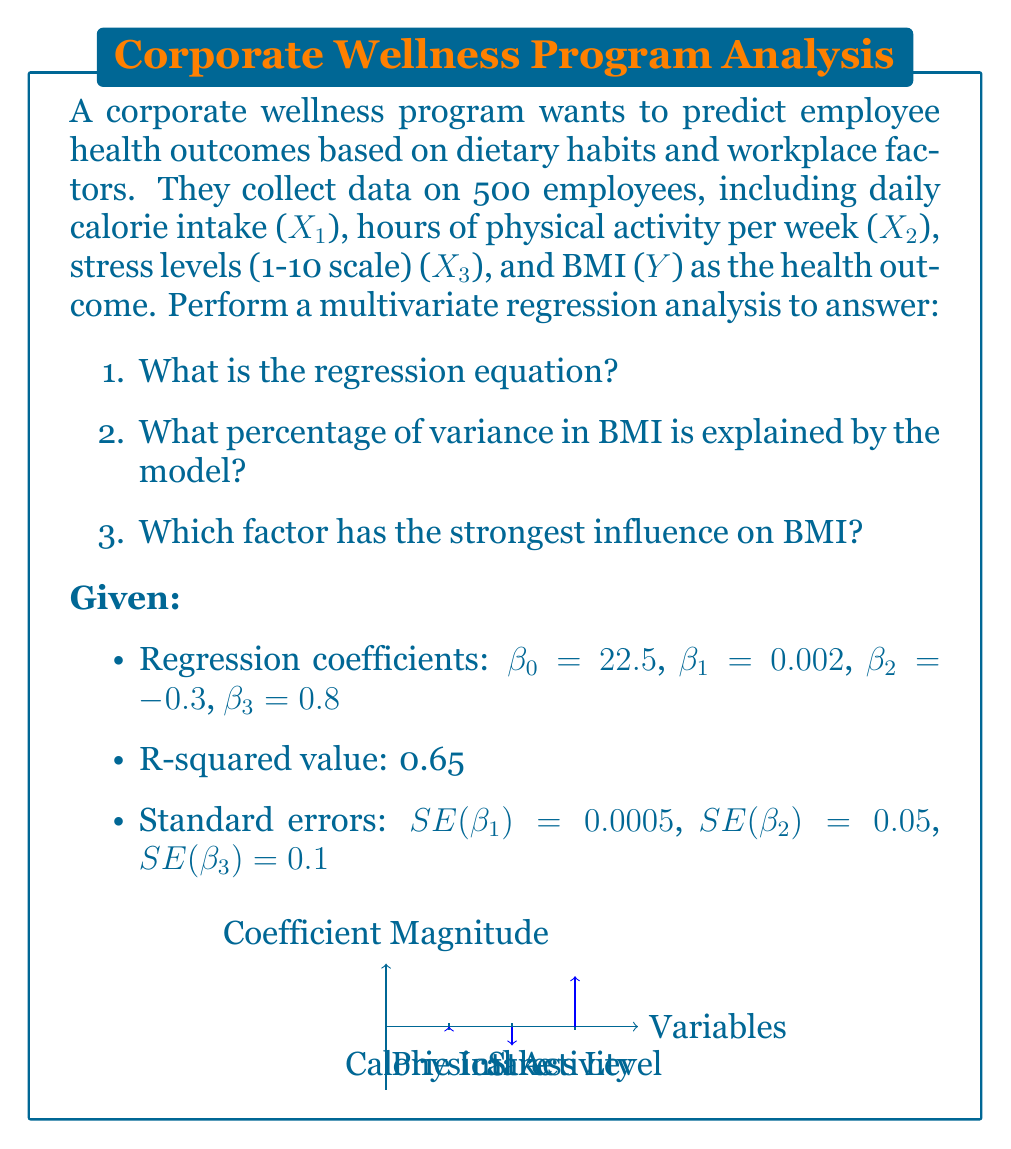Give your solution to this math problem. Let's approach this step-by-step:

1. Regression equation:
   The general form of a multivariate regression equation is:
   $$Y = \beta_0 + \beta_1X_1 + \beta_2X_2 + \beta_3X_3 + \epsilon$$
   
   Substituting the given coefficients:
   $$BMI = 22.5 + 0.002(Calories) - 0.3(Activity) + 0.8(Stress)$$

2. Variance explained:
   The R-squared value directly represents the percentage of variance explained by the model. Given R² = 0.65, this means 65% of the variance in BMI is explained by the model.

3. Strongest influence:
   To determine which factor has the strongest influence, we need to compare the standardized coefficients or t-statistics. Since we don't have standardized coefficients, we'll use t-statistics.

   t-statistic = coefficient / standard error
   
   For Calorie Intake: $t_1 = 0.002 / 0.0005 = 4$
   For Physical Activity: $t_2 = -0.3 / 0.05 = -6$
   For Stress Level: $t_3 = 0.8 / 0.1 = 8$

   The largest absolute t-statistic indicates the strongest influence. In this case, it's Stress Level with a t-statistic of 8.
Answer: 1. $BMI = 22.5 + 0.002(Calories) - 0.3(Activity) + 0.8(Stress)$
2. 65%
3. Stress Level 